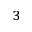Convert formula to latex. <formula><loc_0><loc_0><loc_500><loc_500>^ { 3 }</formula> 